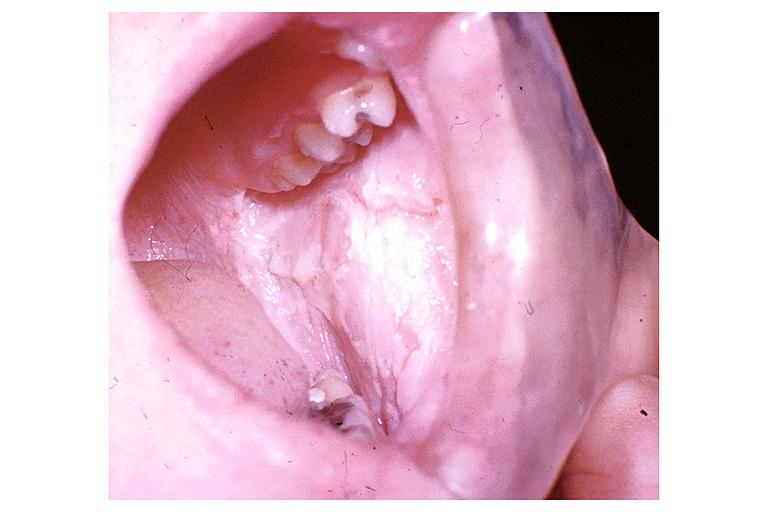does cm show white sponge nevus?
Answer the question using a single word or phrase. No 